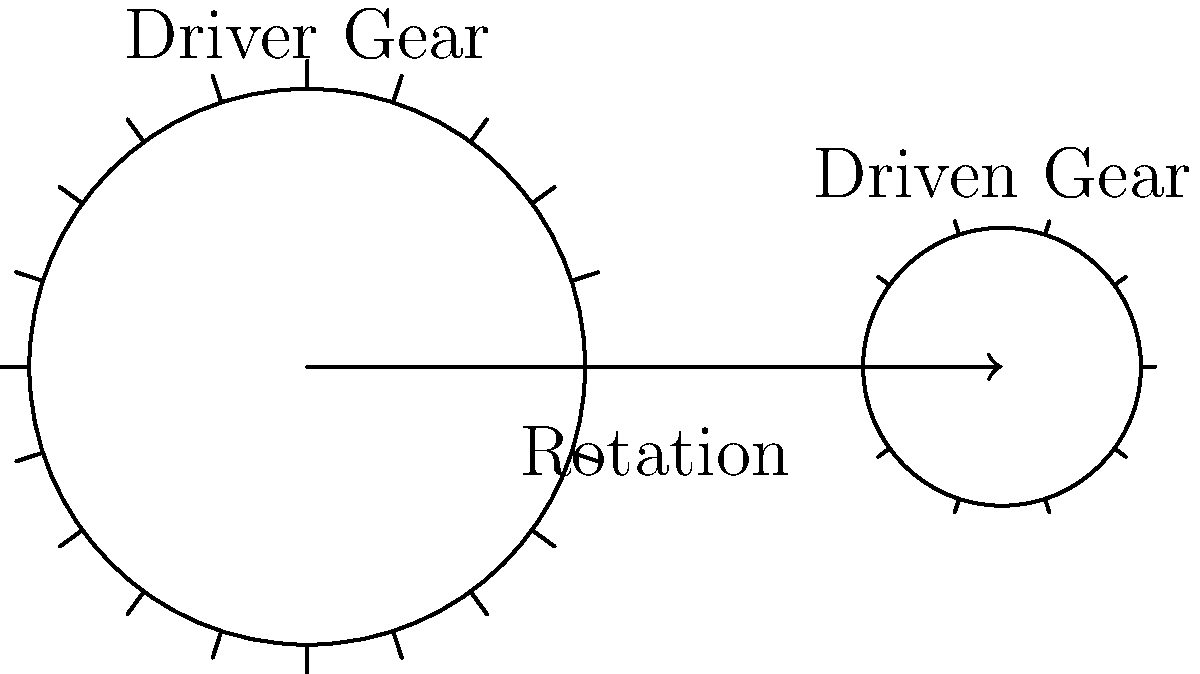In the old steam locomotive you used to ride, the driver gear had 40 teeth and the driven gear had 20 teeth. If the driver gear rotated at 120 RPM and the mechanical efficiency of the system was 85%, what was the output power at the driven gear if the input power was 100 kW? Let's approach this step-by-step:

1) First, we need to calculate the gear ratio:
   Gear ratio = Number of teeth on driven gear / Number of teeth on driver gear
   $$ \text{Gear ratio} = \frac{20}{40} = 0.5 $$

2) Now, let's calculate the speed of the driven gear:
   Speed of driven gear = Speed of driver gear / Gear ratio
   $$ \text{Speed of driven gear} = \frac{120 \text{ RPM}}{0.5} = 240 \text{ RPM} $$

3) The mechanical efficiency is given as 85% or 0.85. This means that 85% of the input power is transferred to the output.

4) We can calculate the output power using the efficiency:
   Output power = Input power × Efficiency
   $$ \text{Output power} = 100 \text{ kW} \times 0.85 = 85 \text{ kW} $$

Therefore, the output power at the driven gear is 85 kW.
Answer: 85 kW 